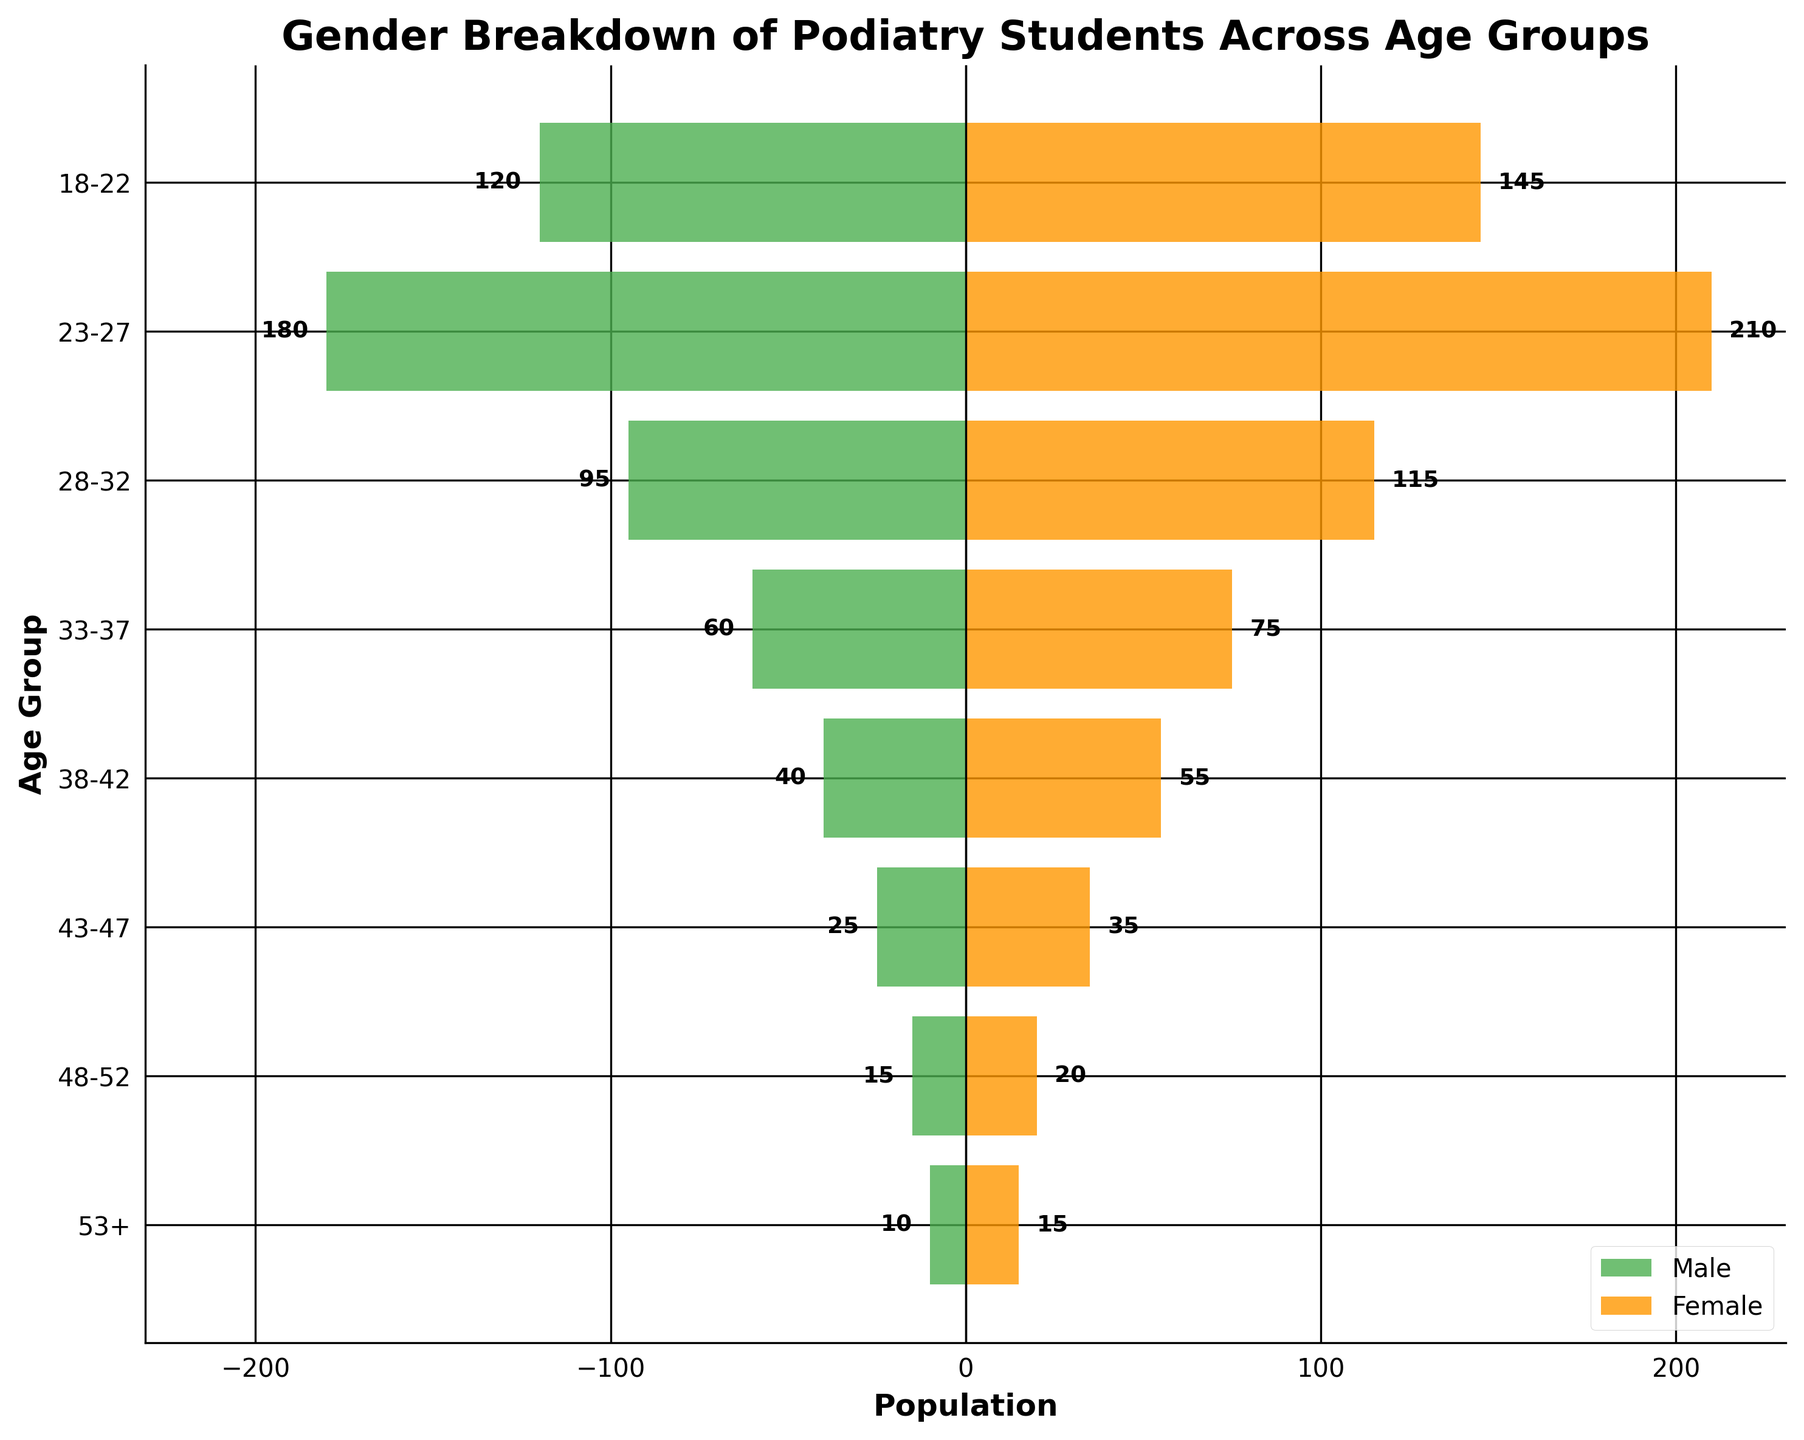What is the title of the figure? The title of the figure is placed at the top and usually describes what the visual represents. In this case, it states the overall content of the data shown in the plot.
Answer: Gender Breakdown of Podiatry Students Across Age Groups Which age group has the highest number of female students? By observing the horizontal orange bars (representing females), the longest bar will indicate the highest number.
Answer: 23-27 What is the total number of male students aged 18-22 and 43-47? To find this, we sum the male students in the 18-22 age group and the 43-47 age group: 120 + 25 = 145
Answer: 145 How many more female students are there than male students in the 33-37 age group? Subtract the number of male students from the number of female students in the 33-37 age group: 75 - 60 = 15
Answer: 15 Which age group has the smallest gender gap, and what is the gap? The gender gap is the absolute difference between the number of male and female students. Calculate for each group and find the smallest. The 48-52 age group has a gap of
Answer: 5 What is the total number of students in the 28-32 age group? Add the number of male and female students in the 28-32 age group: 95 + 115 = 210
Answer: 210 How many more female students are there than male students overall? Sum up all the female students and male students, then find the difference. Male total: 120 + 180 + 95 + 60 + 40 + 25 + 15 + 10 = 545. Female total: 145 + 210 + 115 + 75 + 55 + 35 + 20 + 15 = 670. Difference: 670 - 545 = 125
Answer: 125 Which age group shows the smallest number of students overall? By adding the number of male and female students for each age group, the smallest total indicates the smallest number of students. The 53+ age group has the fewest students.
Answer: 53+ Is the number of female students higher than male students in every age group? Compare the female and male population bar lengths for each age group to see if the female bars are consistently longer.
Answer: Yes 